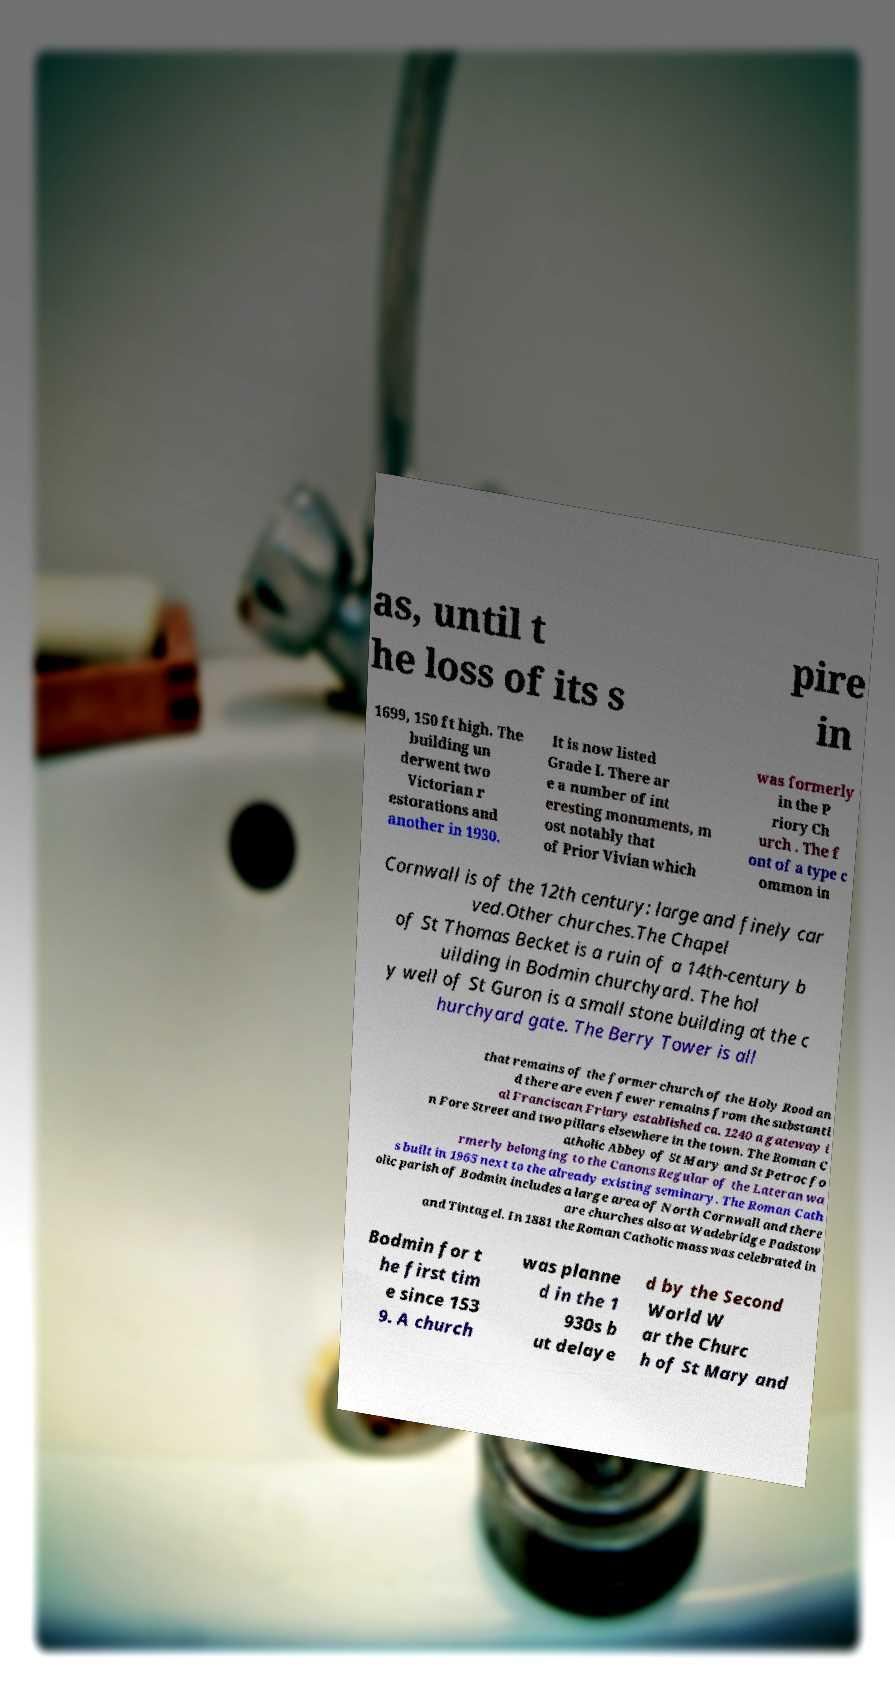Please read and relay the text visible in this image. What does it say? as, until t he loss of its s pire in 1699, 150 ft high. The building un derwent two Victorian r estorations and another in 1930. It is now listed Grade I. There ar e a number of int eresting monuments, m ost notably that of Prior Vivian which was formerly in the P riory Ch urch . The f ont of a type c ommon in Cornwall is of the 12th century: large and finely car ved.Other churches.The Chapel of St Thomas Becket is a ruin of a 14th-century b uilding in Bodmin churchyard. The hol y well of St Guron is a small stone building at the c hurchyard gate. The Berry Tower is all that remains of the former church of the Holy Rood an d there are even fewer remains from the substanti al Franciscan Friary established ca. 1240 a gateway i n Fore Street and two pillars elsewhere in the town. The Roman C atholic Abbey of St Mary and St Petroc fo rmerly belonging to the Canons Regular of the Lateran wa s built in 1965 next to the already existing seminary. The Roman Cath olic parish of Bodmin includes a large area of North Cornwall and there are churches also at Wadebridge Padstow and Tintagel. In 1881 the Roman Catholic mass was celebrated in Bodmin for t he first tim e since 153 9. A church was planne d in the 1 930s b ut delaye d by the Second World W ar the Churc h of St Mary and 